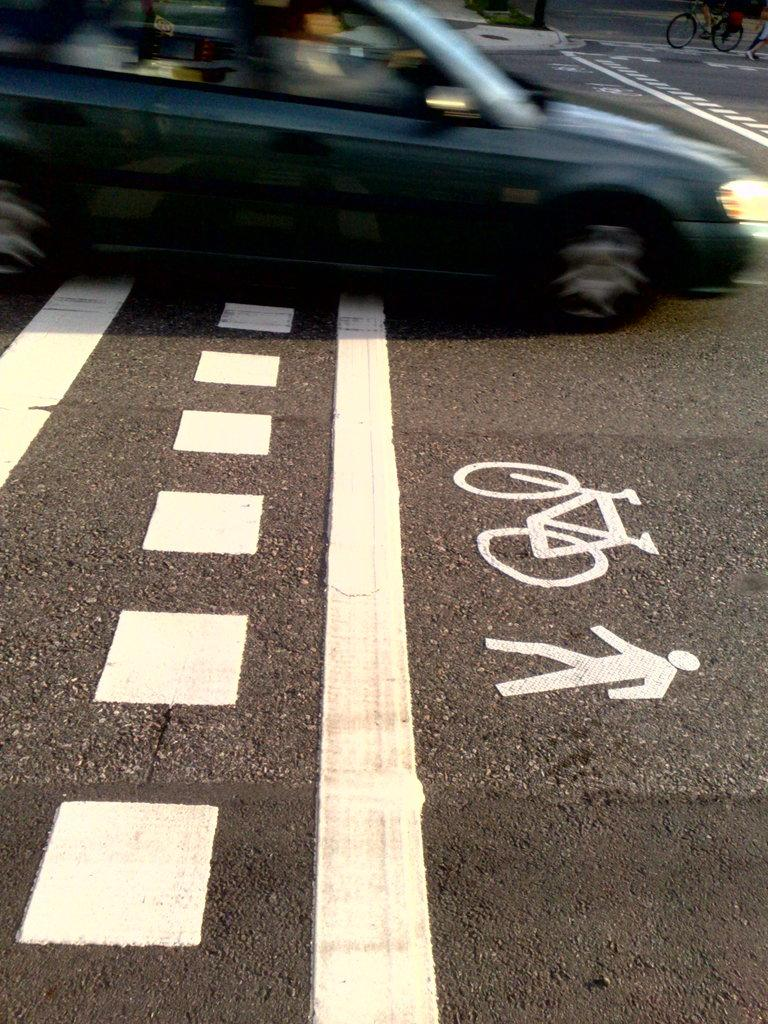What is the main feature of the image? There is a road in the image. What can be seen on the road? The road has symbols on it. What is happening on the road? A car is passing on the road. Are there any other vehicles in the image? Yes, there is a cycle in the image. What type of key is used to lock the church door in the image? There is no church or key present in the image; it only features a road, symbols, a car, and a cycle. 